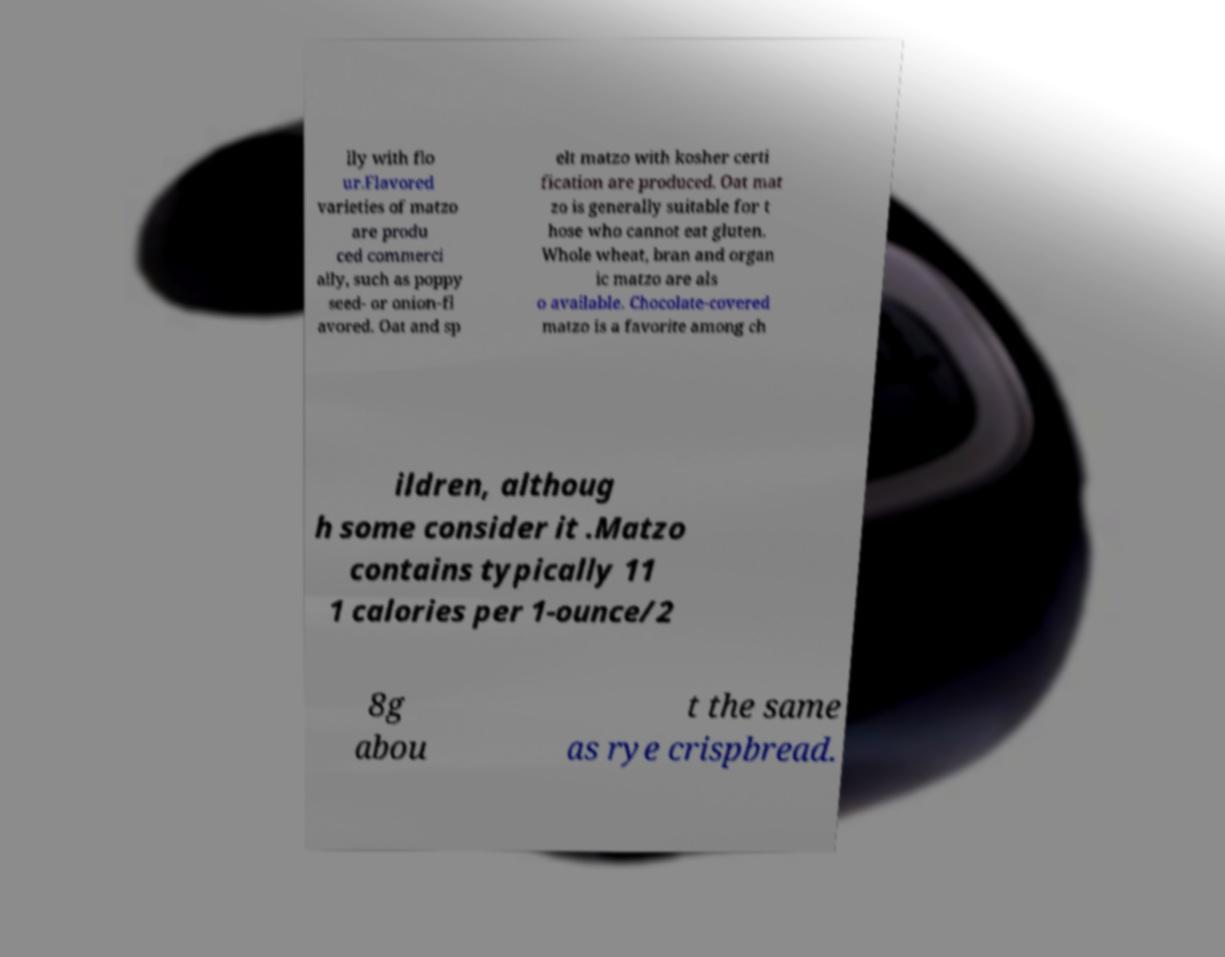Please identify and transcribe the text found in this image. lly with flo ur.Flavored varieties of matzo are produ ced commerci ally, such as poppy seed- or onion-fl avored. Oat and sp elt matzo with kosher certi fication are produced. Oat mat zo is generally suitable for t hose who cannot eat gluten. Whole wheat, bran and organ ic matzo are als o available. Chocolate-covered matzo is a favorite among ch ildren, althoug h some consider it .Matzo contains typically 11 1 calories per 1-ounce/2 8g abou t the same as rye crispbread. 